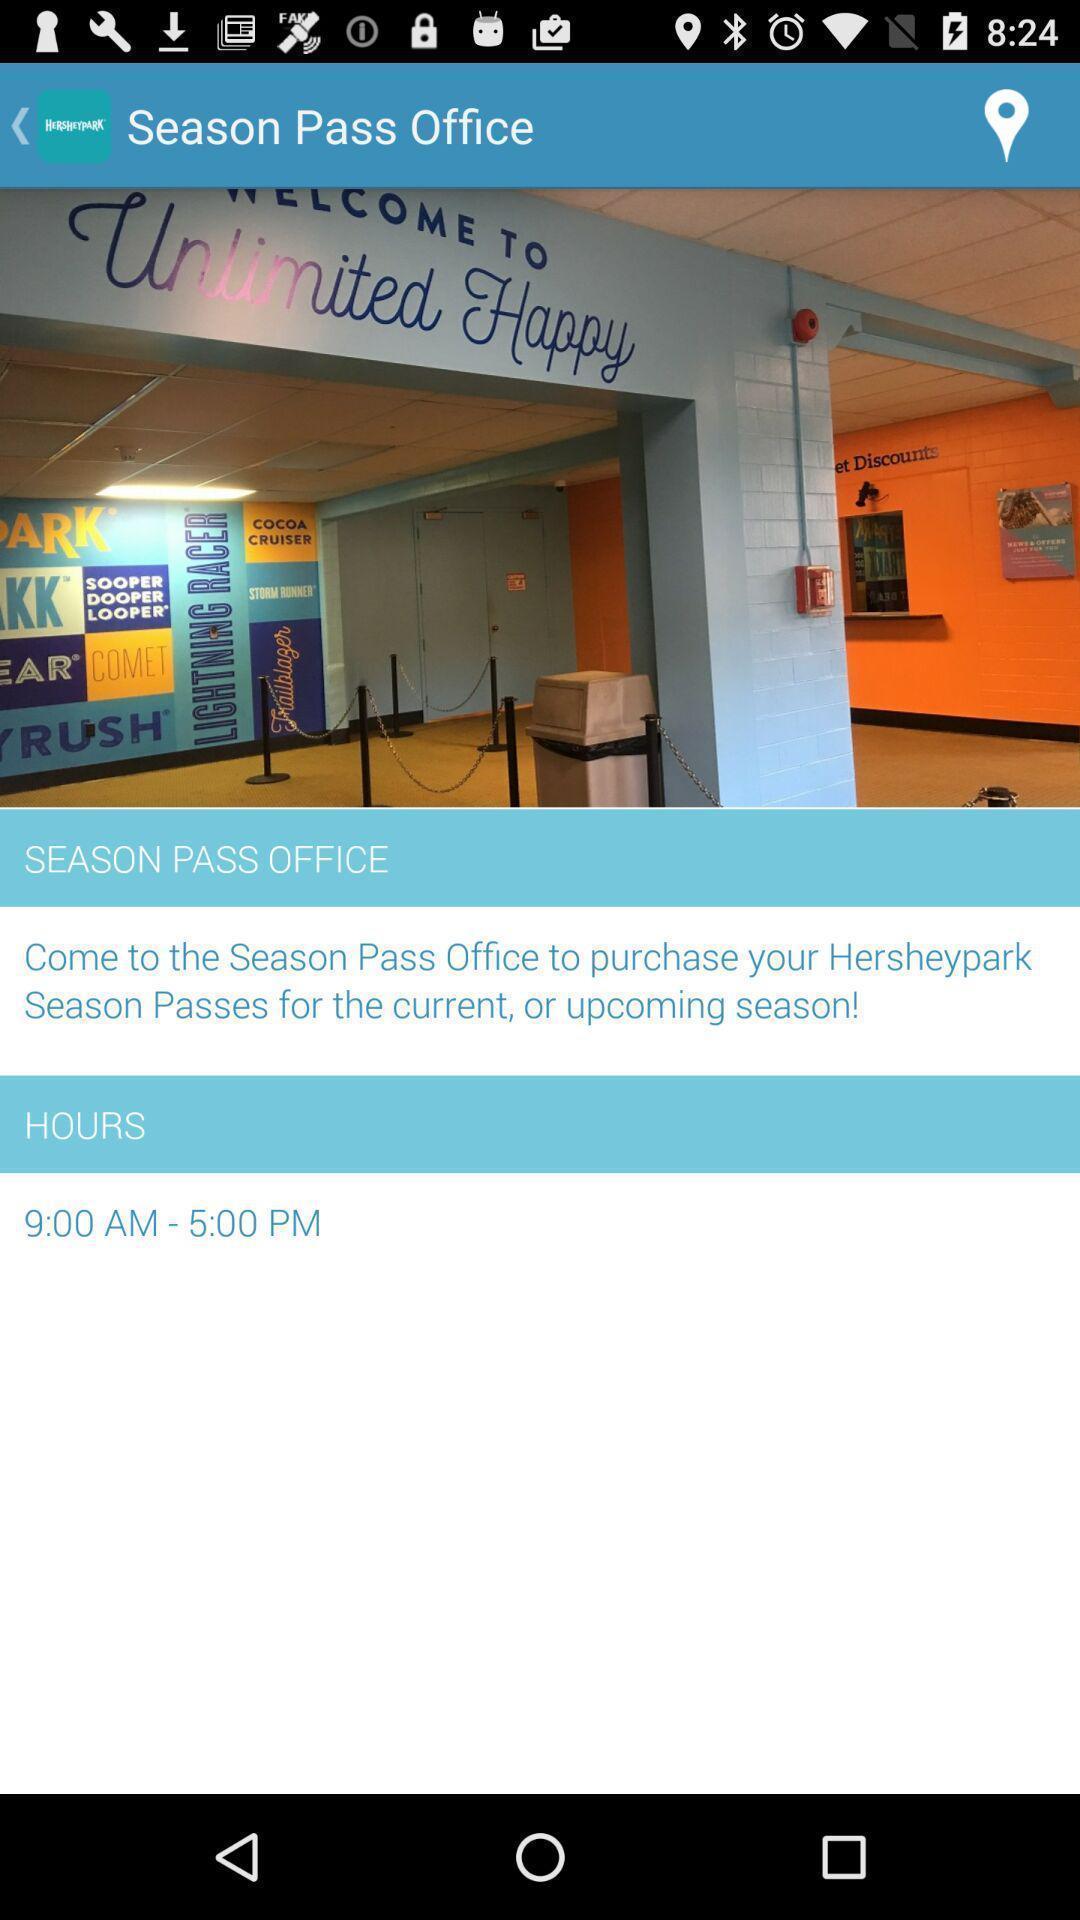What is the overall content of this screenshot? Screen shows season pass office information page. 